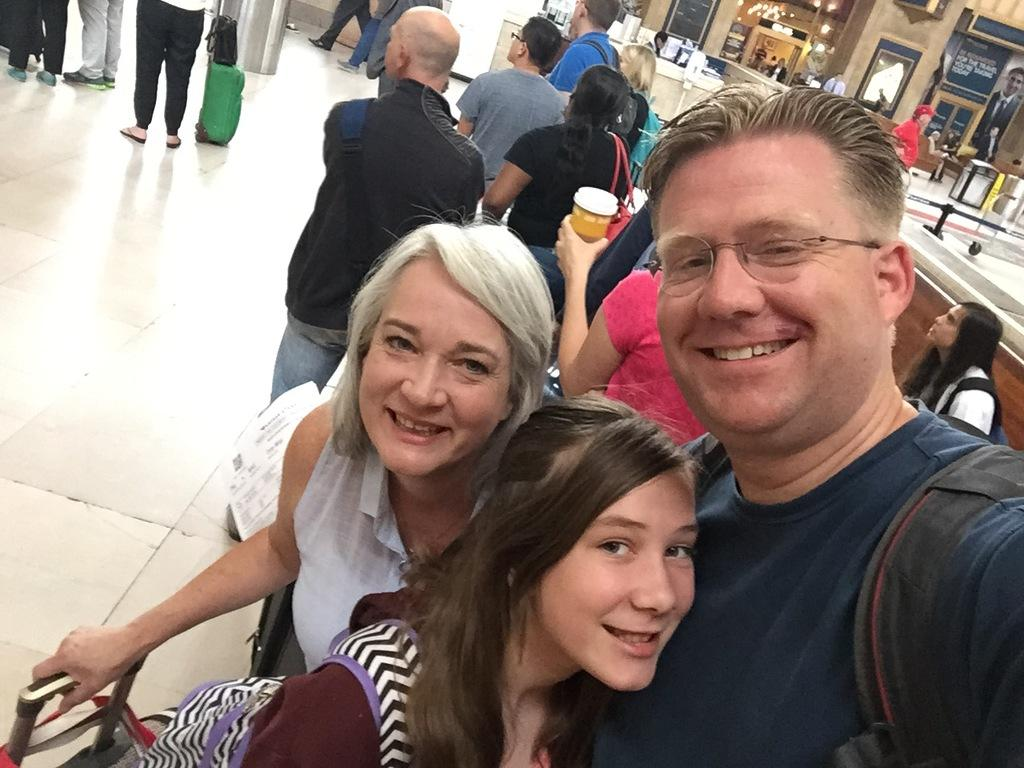What are the three people in the image doing? The three people in the image are taking a selfie. Where is the selfie being taken? The selfie is being taken inside an airport. Can you describe the surroundings in the image? There are many other passengers visible in the image, as well as counters and stores in the background. What type of wren can be seen perched on the counter in the image? There is no wren present in the image; it is set inside an airport with no visible wildlife. 